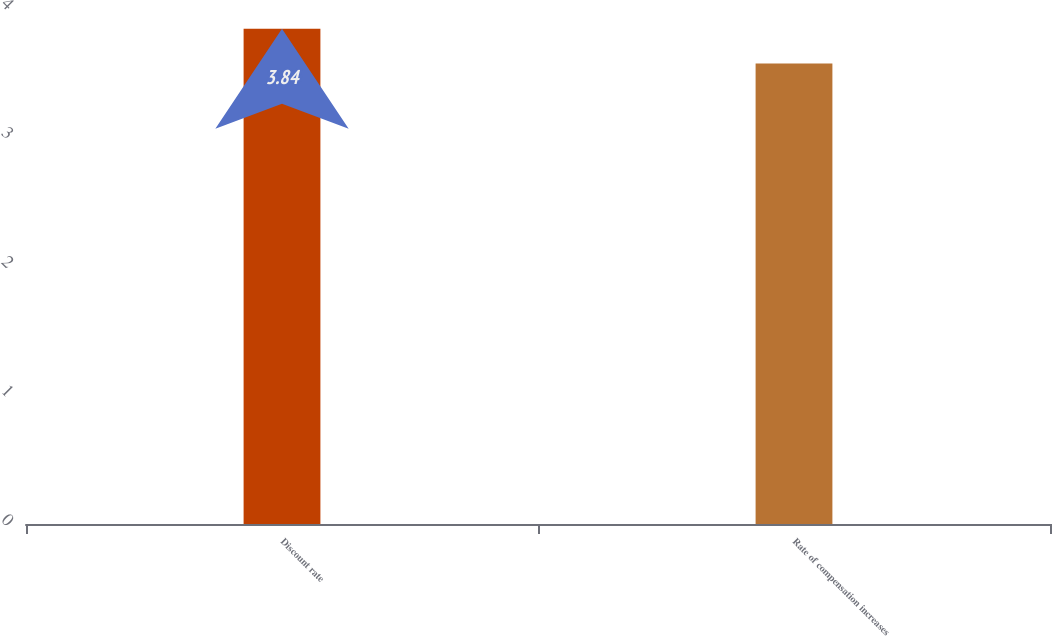Convert chart. <chart><loc_0><loc_0><loc_500><loc_500><bar_chart><fcel>Discount rate<fcel>Rate of compensation increases<nl><fcel>3.84<fcel>3.57<nl></chart> 